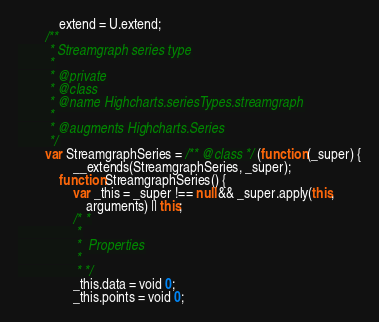<code> <loc_0><loc_0><loc_500><loc_500><_JavaScript_>            extend = U.extend;
        /**
         * Streamgraph series type
         *
         * @private
         * @class
         * @name Highcharts.seriesTypes.streamgraph
         *
         * @augments Highcharts.Series
         */
        var StreamgraphSeries = /** @class */ (function (_super) {
                __extends(StreamgraphSeries, _super);
            function StreamgraphSeries() {
                var _this = _super !== null && _super.apply(this,
                    arguments) || this;
                /* *
                 *
                 *  Properties
                 *
                 * */
                _this.data = void 0;
                _this.points = void 0;</code> 